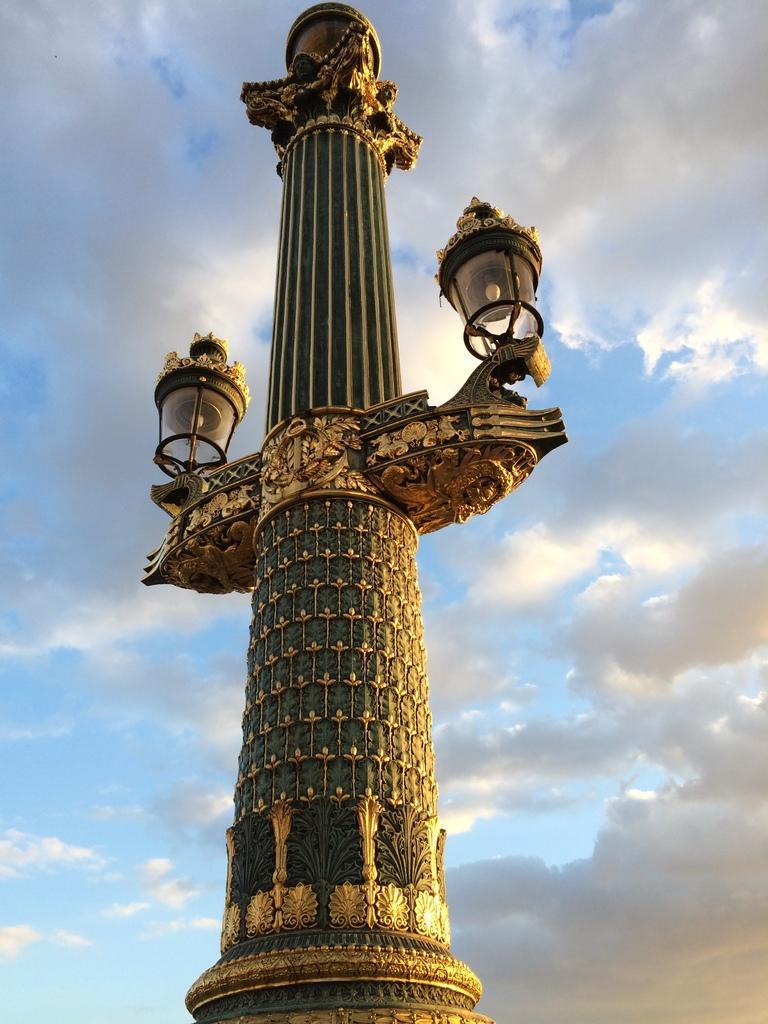How would you summarize this image in a sentence or two? In the foreground of the picture there is a street light. Sky is sunny. 